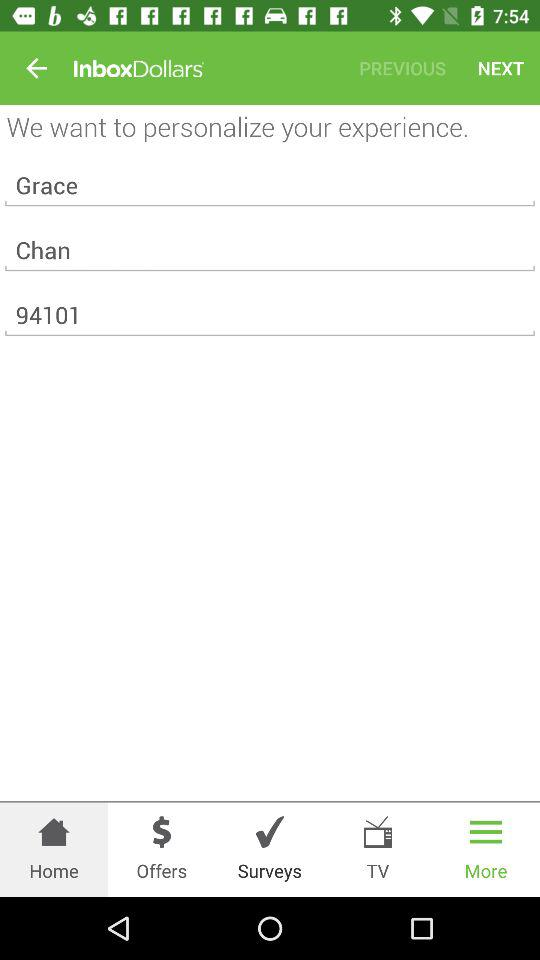Which tab is selected? The selected tab is "More". 